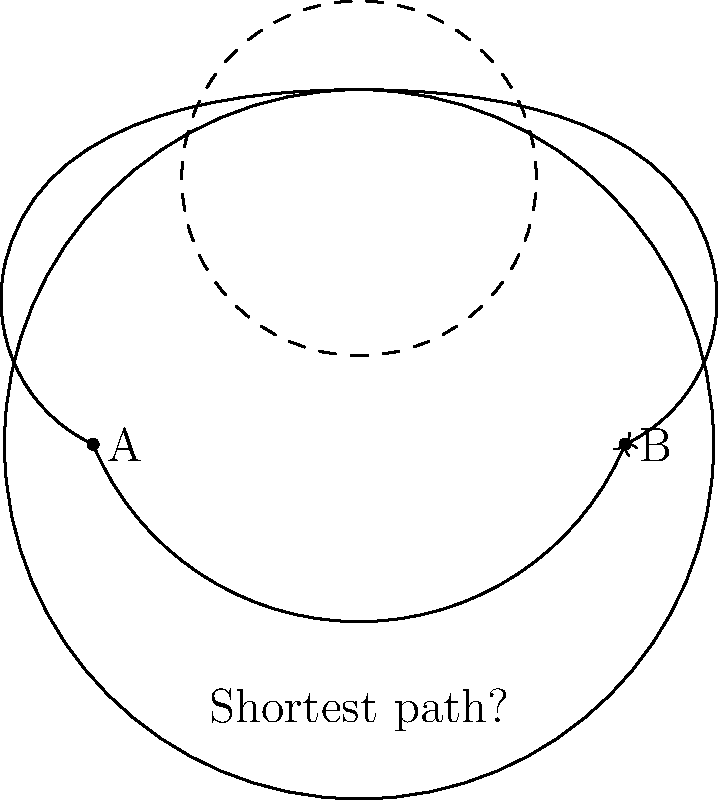Consider a torus (donut shape) with points A and B located on opposite sides of its outer circumference, as shown in the diagram. Which path represents the shortest distance between points A and B on the surface of the torus: the path going around the outside of the torus, or the path going through the center hole? To determine the shortest path between two points on a torus, we need to consider the geometry of the surface:

1. A torus is a non-Euclidean surface, meaning that the shortest path between two points is not always a straight line.

2. The surface of a torus can be represented as a flat rectangle with opposite edges identified. This is called the fundamental domain of the torus.

3. In this representation, the path going around the outside of the torus corresponds to a horizontal line in the rectangular domain.

4. The path going through the center hole corresponds to a vertical line in the rectangular domain.

5. The shortest path between two points on a torus is the geodesic, which is the equivalent of a straight line on a flat surface.

6. In the rectangular representation, the geodesic is the straight line connecting the two points, taking into account the edge identifications.

7. For points A and B located on opposite sides of the outer circumference, the path through the center hole (vertical in the rectangular domain) is shorter than the path around the outside (horizontal in the rectangular domain).

8. This is because the distance through the center hole is approximately equal to the diameter of the torus, while the distance around the outside is approximately equal to half the circumference of the torus.

9. Since the circumference is always greater than the diameter ($C = \pi d$), the path through the center hole is shorter.

Therefore, the shortest path between points A and B on the surface of the torus is the one going through the center hole.
Answer: The path through the center hole 